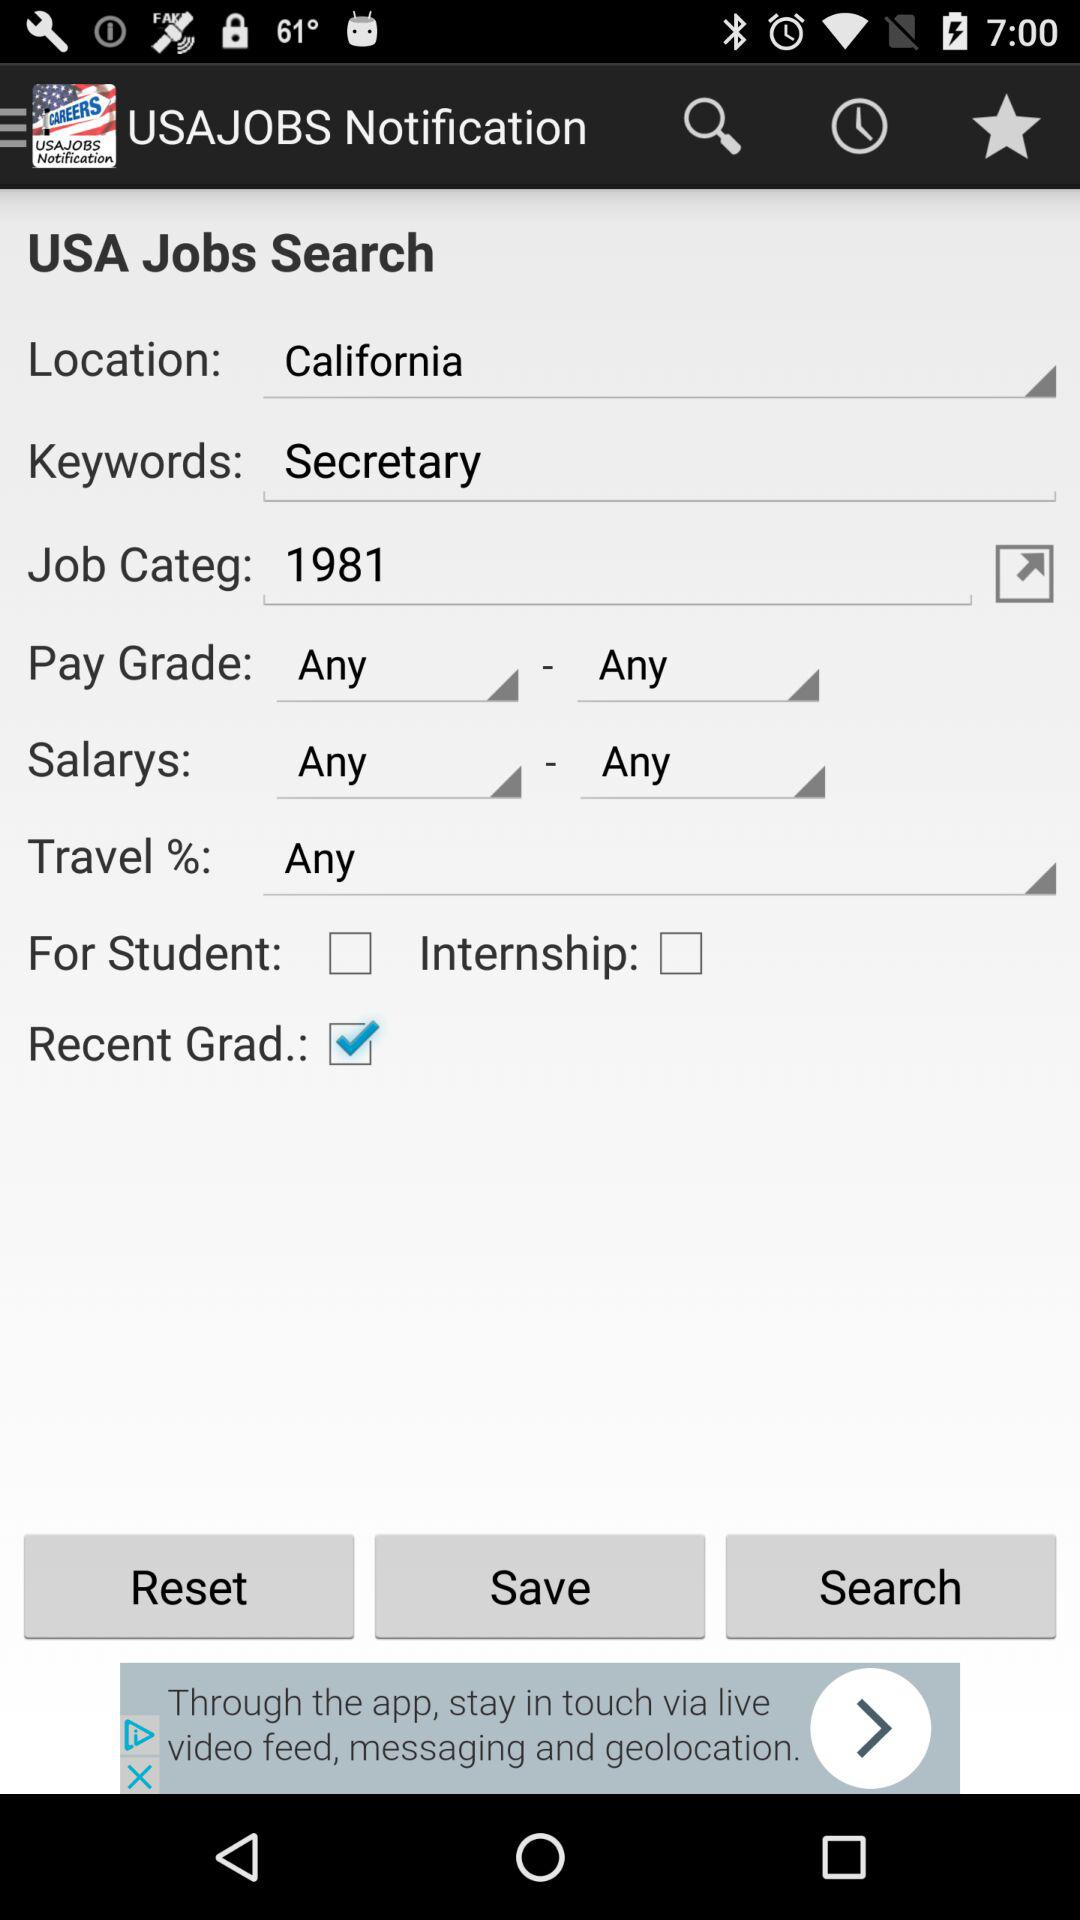What city is entered?
When the provided information is insufficient, respond with <no answer>. <no answer> 